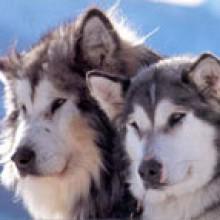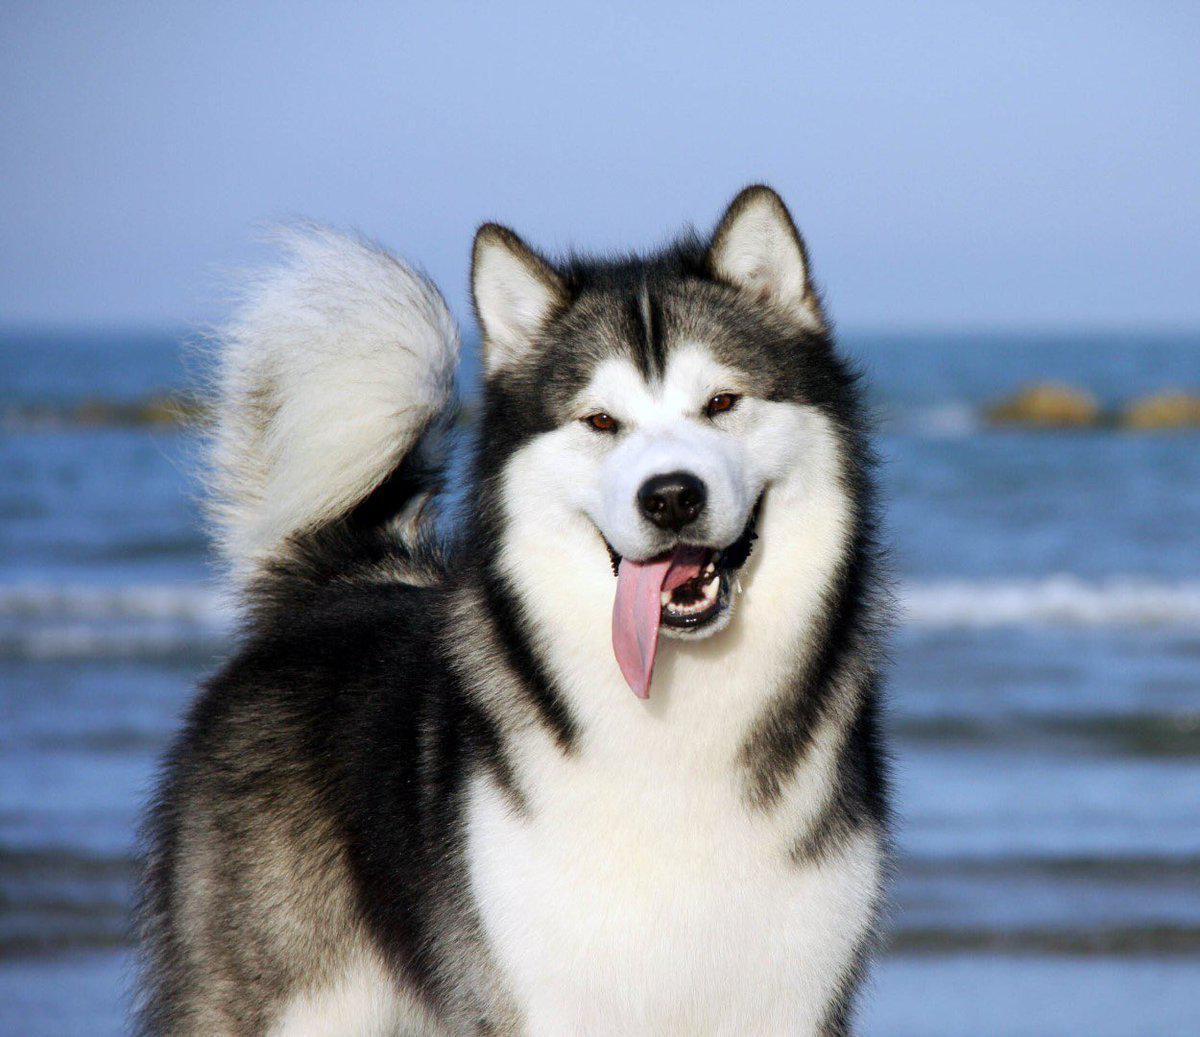The first image is the image on the left, the second image is the image on the right. Given the left and right images, does the statement "The right image contains one dog, who is looking at the camera with a smiling face and his tongue hanging down past his chin." hold true? Answer yes or no. Yes. The first image is the image on the left, the second image is the image on the right. Assess this claim about the two images: "The left and right image contains a total of three dogs with at least two in the snow.". Correct or not? Answer yes or no. No. 